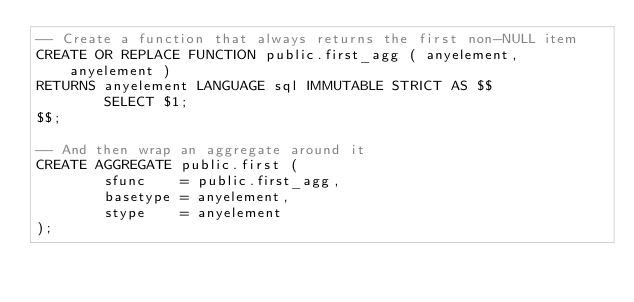<code> <loc_0><loc_0><loc_500><loc_500><_SQL_>-- Create a function that always returns the first non-NULL item
CREATE OR REPLACE FUNCTION public.first_agg ( anyelement, anyelement )
RETURNS anyelement LANGUAGE sql IMMUTABLE STRICT AS $$
        SELECT $1;
$$;

-- And then wrap an aggregate around it
CREATE AGGREGATE public.first (
        sfunc    = public.first_agg,
        basetype = anyelement,
        stype    = anyelement
);
</code> 